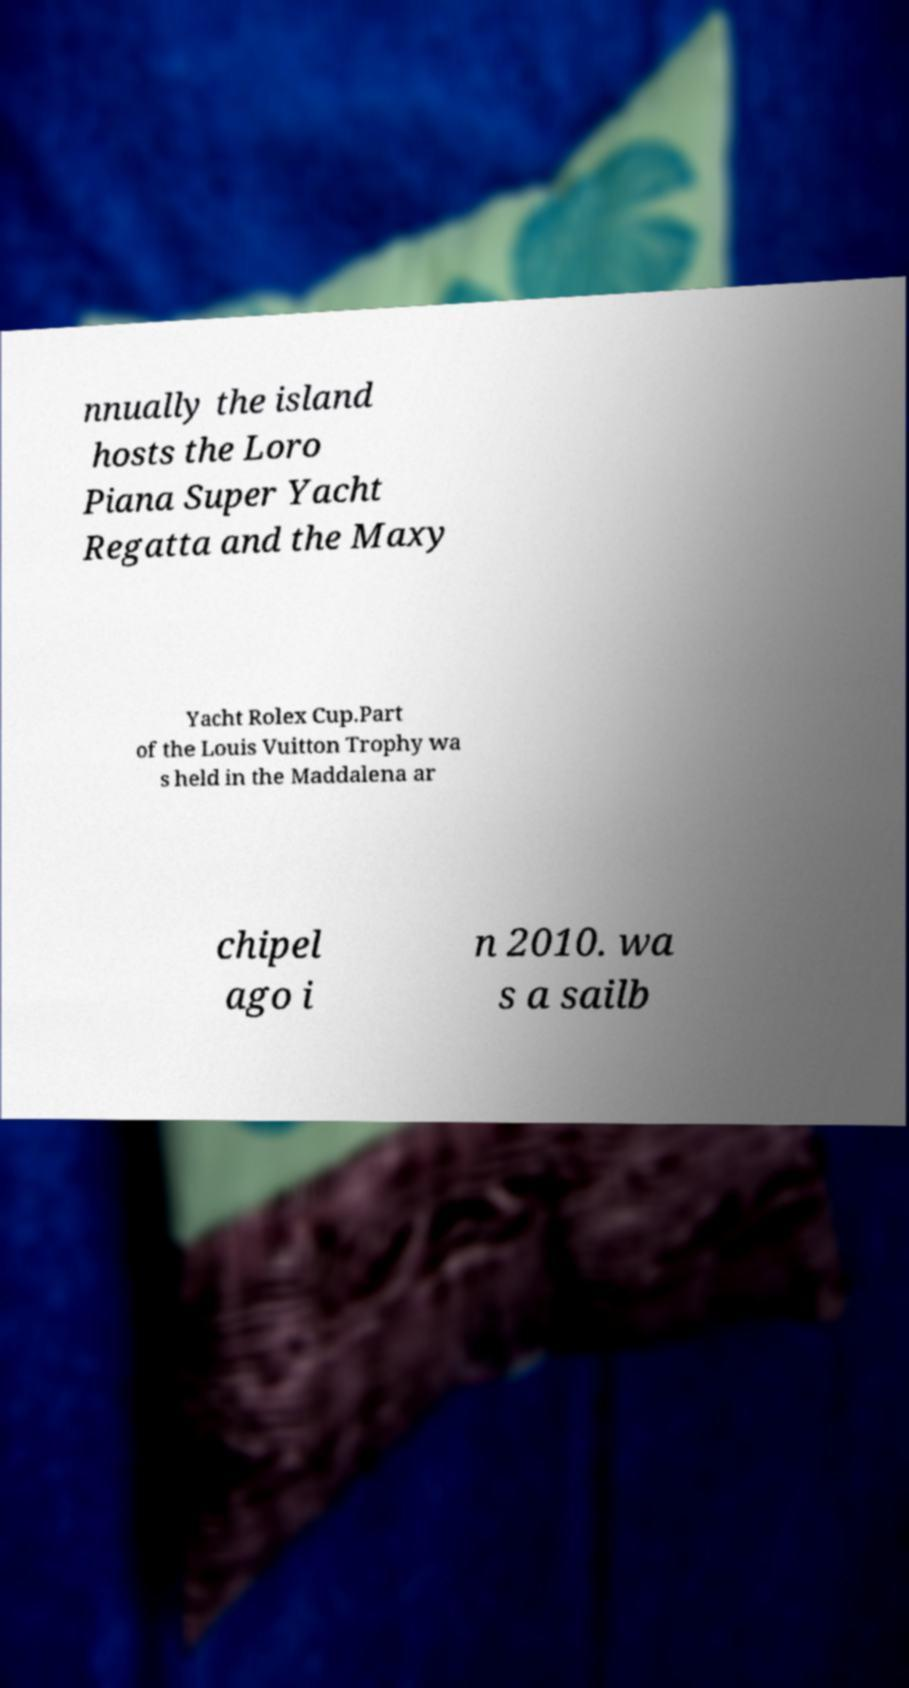What messages or text are displayed in this image? I need them in a readable, typed format. nnually the island hosts the Loro Piana Super Yacht Regatta and the Maxy Yacht Rolex Cup.Part of the Louis Vuitton Trophy wa s held in the Maddalena ar chipel ago i n 2010. wa s a sailb 